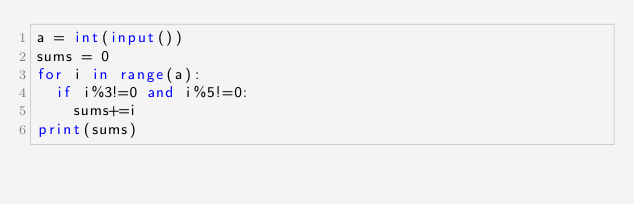<code> <loc_0><loc_0><loc_500><loc_500><_Python_>a = int(input())
sums = 0
for i in range(a):
  if i%3!=0 and i%5!=0:
    sums+=i
print(sums)</code> 